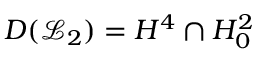<formula> <loc_0><loc_0><loc_500><loc_500>D ( \mathcal { L } _ { 2 } ) = H ^ { 4 } \cap H _ { 0 } ^ { 2 }</formula> 